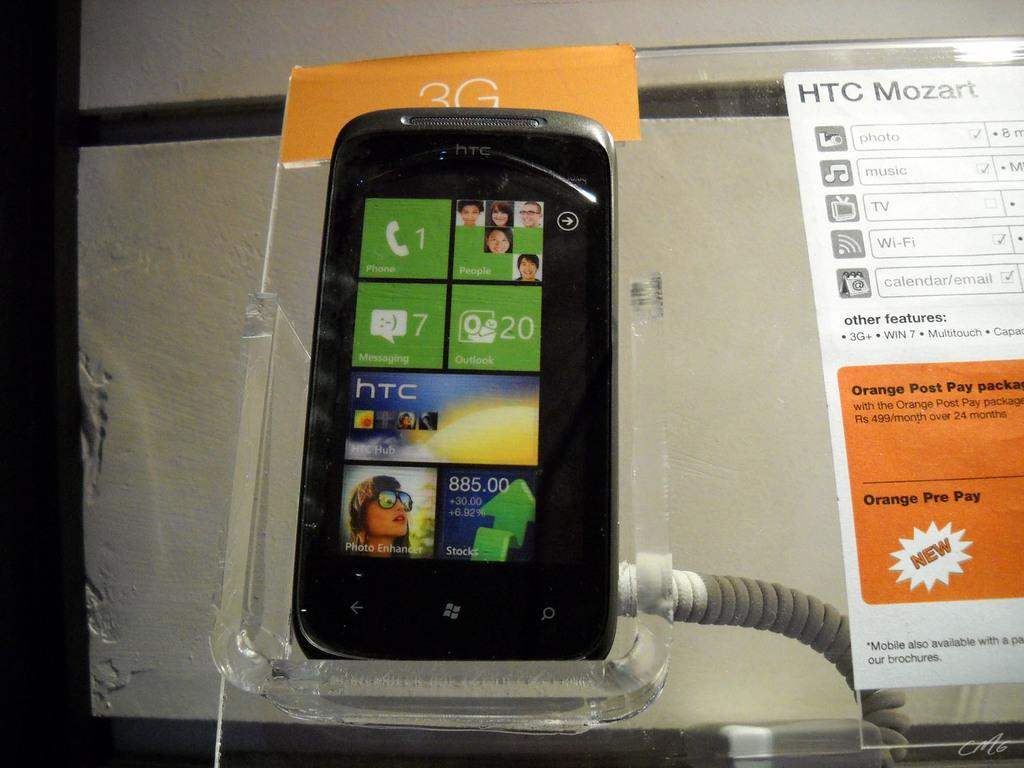<image>
Describe the image concisely. A hTc smartphone inside a case with a HTC Mozart manual beside 